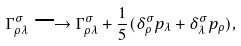Convert formula to latex. <formula><loc_0><loc_0><loc_500><loc_500>\Gamma ^ { \sigma } _ { \rho \lambda } \longrightarrow \Gamma ^ { \sigma } _ { \rho \lambda } + \frac { 1 } { 5 } ( \delta ^ { \sigma } _ { \rho } p _ { \lambda } + \delta ^ { \sigma } _ { \lambda } p _ { \rho } ) ,</formula> 